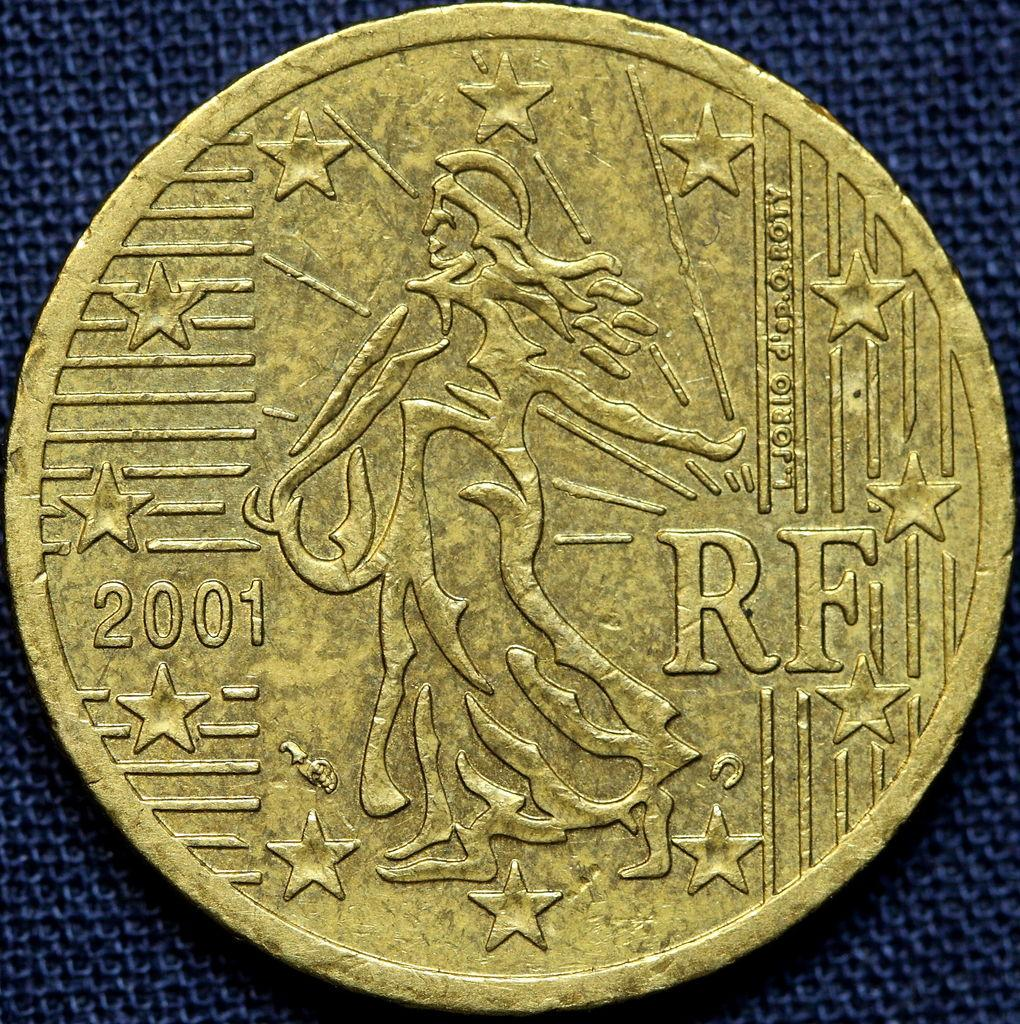Provide a one-sentence caption for the provided image. A coin has a section missing and is dated 2001. 